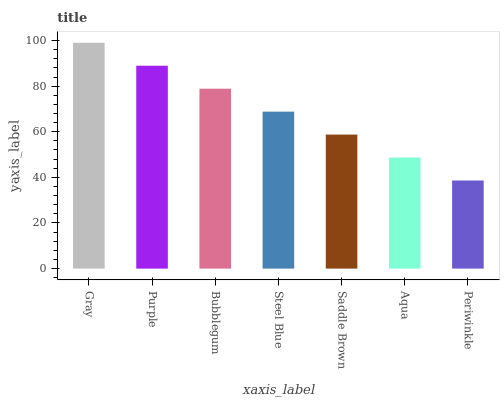Is Periwinkle the minimum?
Answer yes or no. Yes. Is Gray the maximum?
Answer yes or no. Yes. Is Purple the minimum?
Answer yes or no. No. Is Purple the maximum?
Answer yes or no. No. Is Gray greater than Purple?
Answer yes or no. Yes. Is Purple less than Gray?
Answer yes or no. Yes. Is Purple greater than Gray?
Answer yes or no. No. Is Gray less than Purple?
Answer yes or no. No. Is Steel Blue the high median?
Answer yes or no. Yes. Is Steel Blue the low median?
Answer yes or no. Yes. Is Periwinkle the high median?
Answer yes or no. No. Is Gray the low median?
Answer yes or no. No. 